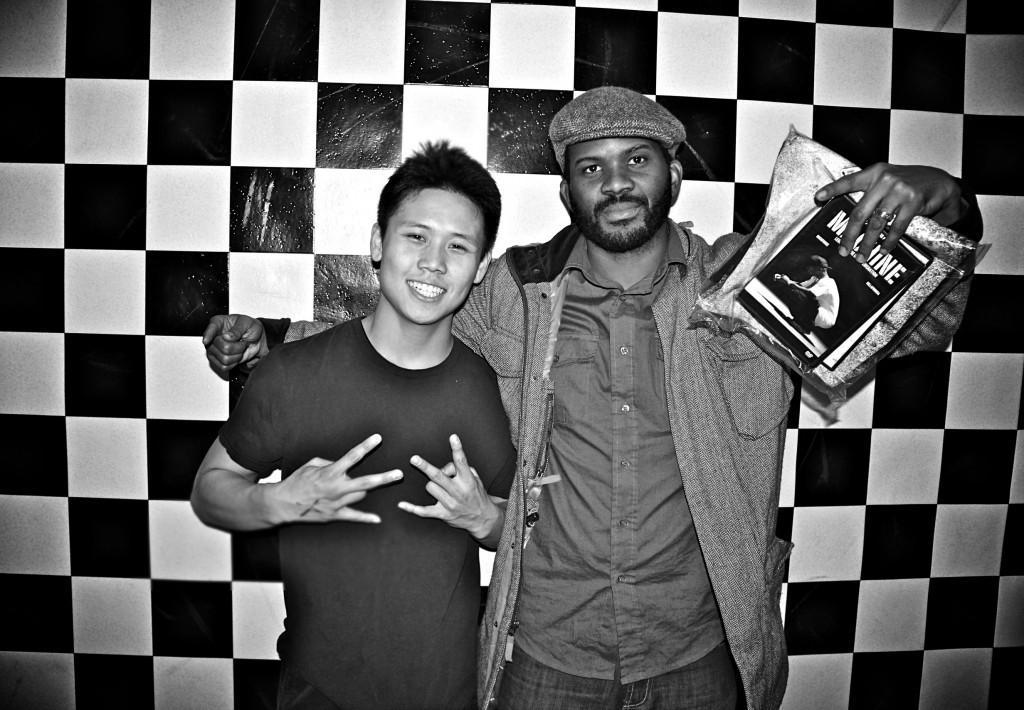Describe this image in one or two sentences. In the middle of the image two persons are standing, smiling and he is holding a cover. Behind them we can see a wall. 